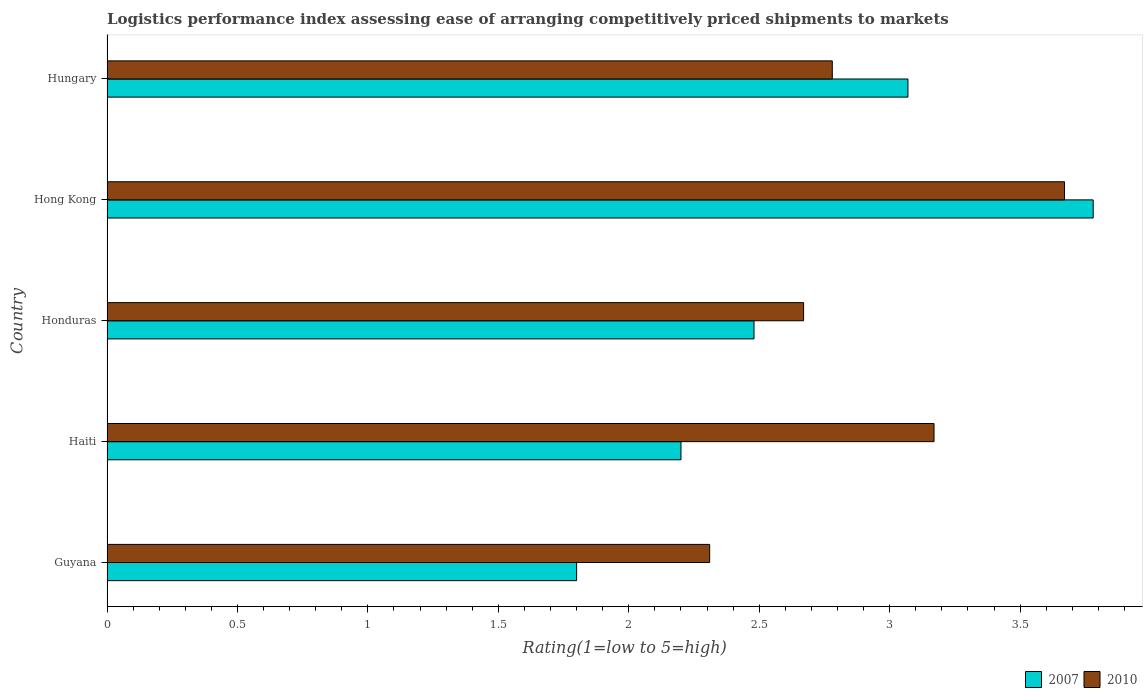Are the number of bars on each tick of the Y-axis equal?
Make the answer very short. Yes. How many bars are there on the 1st tick from the top?
Provide a succinct answer. 2. How many bars are there on the 1st tick from the bottom?
Your answer should be compact. 2. What is the label of the 1st group of bars from the top?
Your response must be concise. Hungary. What is the Logistic performance index in 2010 in Hong Kong?
Provide a short and direct response. 3.67. Across all countries, what is the maximum Logistic performance index in 2007?
Provide a succinct answer. 3.78. Across all countries, what is the minimum Logistic performance index in 2007?
Make the answer very short. 1.8. In which country was the Logistic performance index in 2010 maximum?
Provide a short and direct response. Hong Kong. In which country was the Logistic performance index in 2010 minimum?
Provide a succinct answer. Guyana. What is the total Logistic performance index in 2010 in the graph?
Provide a short and direct response. 14.6. What is the difference between the Logistic performance index in 2010 in Hong Kong and that in Hungary?
Offer a very short reply. 0.89. What is the difference between the Logistic performance index in 2007 in Hong Kong and the Logistic performance index in 2010 in Haiti?
Offer a very short reply. 0.61. What is the average Logistic performance index in 2010 per country?
Provide a short and direct response. 2.92. What is the difference between the Logistic performance index in 2007 and Logistic performance index in 2010 in Haiti?
Offer a very short reply. -0.97. What is the ratio of the Logistic performance index in 2007 in Haiti to that in Honduras?
Provide a succinct answer. 0.89. Is the Logistic performance index in 2007 in Honduras less than that in Hong Kong?
Give a very brief answer. Yes. Is the difference between the Logistic performance index in 2007 in Guyana and Honduras greater than the difference between the Logistic performance index in 2010 in Guyana and Honduras?
Your answer should be very brief. No. What is the difference between the highest and the lowest Logistic performance index in 2010?
Give a very brief answer. 1.36. In how many countries, is the Logistic performance index in 2007 greater than the average Logistic performance index in 2007 taken over all countries?
Your answer should be compact. 2. What does the 1st bar from the top in Hungary represents?
Offer a terse response. 2010. What does the 2nd bar from the bottom in Honduras represents?
Keep it short and to the point. 2010. Are all the bars in the graph horizontal?
Your response must be concise. Yes. What is the difference between two consecutive major ticks on the X-axis?
Make the answer very short. 0.5. Are the values on the major ticks of X-axis written in scientific E-notation?
Offer a terse response. No. Does the graph contain any zero values?
Provide a short and direct response. No. Where does the legend appear in the graph?
Your answer should be compact. Bottom right. How are the legend labels stacked?
Offer a terse response. Horizontal. What is the title of the graph?
Give a very brief answer. Logistics performance index assessing ease of arranging competitively priced shipments to markets. Does "1998" appear as one of the legend labels in the graph?
Your answer should be compact. No. What is the label or title of the X-axis?
Your response must be concise. Rating(1=low to 5=high). What is the label or title of the Y-axis?
Offer a terse response. Country. What is the Rating(1=low to 5=high) in 2007 in Guyana?
Your response must be concise. 1.8. What is the Rating(1=low to 5=high) in 2010 in Guyana?
Provide a succinct answer. 2.31. What is the Rating(1=low to 5=high) in 2007 in Haiti?
Your answer should be very brief. 2.2. What is the Rating(1=low to 5=high) in 2010 in Haiti?
Keep it short and to the point. 3.17. What is the Rating(1=low to 5=high) of 2007 in Honduras?
Give a very brief answer. 2.48. What is the Rating(1=low to 5=high) in 2010 in Honduras?
Keep it short and to the point. 2.67. What is the Rating(1=low to 5=high) of 2007 in Hong Kong?
Ensure brevity in your answer.  3.78. What is the Rating(1=low to 5=high) in 2010 in Hong Kong?
Keep it short and to the point. 3.67. What is the Rating(1=low to 5=high) in 2007 in Hungary?
Your answer should be very brief. 3.07. What is the Rating(1=low to 5=high) of 2010 in Hungary?
Your response must be concise. 2.78. Across all countries, what is the maximum Rating(1=low to 5=high) of 2007?
Your response must be concise. 3.78. Across all countries, what is the maximum Rating(1=low to 5=high) of 2010?
Your answer should be compact. 3.67. Across all countries, what is the minimum Rating(1=low to 5=high) in 2007?
Provide a succinct answer. 1.8. Across all countries, what is the minimum Rating(1=low to 5=high) in 2010?
Keep it short and to the point. 2.31. What is the total Rating(1=low to 5=high) of 2007 in the graph?
Your answer should be very brief. 13.33. What is the difference between the Rating(1=low to 5=high) in 2007 in Guyana and that in Haiti?
Keep it short and to the point. -0.4. What is the difference between the Rating(1=low to 5=high) of 2010 in Guyana and that in Haiti?
Keep it short and to the point. -0.86. What is the difference between the Rating(1=low to 5=high) in 2007 in Guyana and that in Honduras?
Offer a terse response. -0.68. What is the difference between the Rating(1=low to 5=high) in 2010 in Guyana and that in Honduras?
Provide a succinct answer. -0.36. What is the difference between the Rating(1=low to 5=high) in 2007 in Guyana and that in Hong Kong?
Your answer should be very brief. -1.98. What is the difference between the Rating(1=low to 5=high) of 2010 in Guyana and that in Hong Kong?
Make the answer very short. -1.36. What is the difference between the Rating(1=low to 5=high) in 2007 in Guyana and that in Hungary?
Your response must be concise. -1.27. What is the difference between the Rating(1=low to 5=high) in 2010 in Guyana and that in Hungary?
Provide a succinct answer. -0.47. What is the difference between the Rating(1=low to 5=high) of 2007 in Haiti and that in Honduras?
Ensure brevity in your answer.  -0.28. What is the difference between the Rating(1=low to 5=high) of 2010 in Haiti and that in Honduras?
Provide a succinct answer. 0.5. What is the difference between the Rating(1=low to 5=high) in 2007 in Haiti and that in Hong Kong?
Make the answer very short. -1.58. What is the difference between the Rating(1=low to 5=high) in 2007 in Haiti and that in Hungary?
Give a very brief answer. -0.87. What is the difference between the Rating(1=low to 5=high) of 2010 in Haiti and that in Hungary?
Give a very brief answer. 0.39. What is the difference between the Rating(1=low to 5=high) in 2010 in Honduras and that in Hong Kong?
Make the answer very short. -1. What is the difference between the Rating(1=low to 5=high) in 2007 in Honduras and that in Hungary?
Your response must be concise. -0.59. What is the difference between the Rating(1=low to 5=high) of 2010 in Honduras and that in Hungary?
Your answer should be very brief. -0.11. What is the difference between the Rating(1=low to 5=high) of 2007 in Hong Kong and that in Hungary?
Your response must be concise. 0.71. What is the difference between the Rating(1=low to 5=high) in 2010 in Hong Kong and that in Hungary?
Make the answer very short. 0.89. What is the difference between the Rating(1=low to 5=high) in 2007 in Guyana and the Rating(1=low to 5=high) in 2010 in Haiti?
Your response must be concise. -1.37. What is the difference between the Rating(1=low to 5=high) in 2007 in Guyana and the Rating(1=low to 5=high) in 2010 in Honduras?
Ensure brevity in your answer.  -0.87. What is the difference between the Rating(1=low to 5=high) of 2007 in Guyana and the Rating(1=low to 5=high) of 2010 in Hong Kong?
Give a very brief answer. -1.87. What is the difference between the Rating(1=low to 5=high) of 2007 in Guyana and the Rating(1=low to 5=high) of 2010 in Hungary?
Ensure brevity in your answer.  -0.98. What is the difference between the Rating(1=low to 5=high) in 2007 in Haiti and the Rating(1=low to 5=high) in 2010 in Honduras?
Ensure brevity in your answer.  -0.47. What is the difference between the Rating(1=low to 5=high) in 2007 in Haiti and the Rating(1=low to 5=high) in 2010 in Hong Kong?
Your answer should be very brief. -1.47. What is the difference between the Rating(1=low to 5=high) of 2007 in Haiti and the Rating(1=low to 5=high) of 2010 in Hungary?
Make the answer very short. -0.58. What is the difference between the Rating(1=low to 5=high) in 2007 in Honduras and the Rating(1=low to 5=high) in 2010 in Hong Kong?
Ensure brevity in your answer.  -1.19. What is the average Rating(1=low to 5=high) in 2007 per country?
Keep it short and to the point. 2.67. What is the average Rating(1=low to 5=high) in 2010 per country?
Give a very brief answer. 2.92. What is the difference between the Rating(1=low to 5=high) of 2007 and Rating(1=low to 5=high) of 2010 in Guyana?
Your answer should be very brief. -0.51. What is the difference between the Rating(1=low to 5=high) of 2007 and Rating(1=low to 5=high) of 2010 in Haiti?
Your answer should be compact. -0.97. What is the difference between the Rating(1=low to 5=high) in 2007 and Rating(1=low to 5=high) in 2010 in Honduras?
Offer a very short reply. -0.19. What is the difference between the Rating(1=low to 5=high) of 2007 and Rating(1=low to 5=high) of 2010 in Hong Kong?
Make the answer very short. 0.11. What is the difference between the Rating(1=low to 5=high) of 2007 and Rating(1=low to 5=high) of 2010 in Hungary?
Provide a succinct answer. 0.29. What is the ratio of the Rating(1=low to 5=high) of 2007 in Guyana to that in Haiti?
Ensure brevity in your answer.  0.82. What is the ratio of the Rating(1=low to 5=high) in 2010 in Guyana to that in Haiti?
Provide a short and direct response. 0.73. What is the ratio of the Rating(1=low to 5=high) of 2007 in Guyana to that in Honduras?
Your answer should be very brief. 0.73. What is the ratio of the Rating(1=low to 5=high) in 2010 in Guyana to that in Honduras?
Provide a succinct answer. 0.87. What is the ratio of the Rating(1=low to 5=high) of 2007 in Guyana to that in Hong Kong?
Provide a short and direct response. 0.48. What is the ratio of the Rating(1=low to 5=high) in 2010 in Guyana to that in Hong Kong?
Give a very brief answer. 0.63. What is the ratio of the Rating(1=low to 5=high) in 2007 in Guyana to that in Hungary?
Provide a short and direct response. 0.59. What is the ratio of the Rating(1=low to 5=high) in 2010 in Guyana to that in Hungary?
Your answer should be very brief. 0.83. What is the ratio of the Rating(1=low to 5=high) of 2007 in Haiti to that in Honduras?
Provide a succinct answer. 0.89. What is the ratio of the Rating(1=low to 5=high) of 2010 in Haiti to that in Honduras?
Provide a short and direct response. 1.19. What is the ratio of the Rating(1=low to 5=high) in 2007 in Haiti to that in Hong Kong?
Keep it short and to the point. 0.58. What is the ratio of the Rating(1=low to 5=high) of 2010 in Haiti to that in Hong Kong?
Ensure brevity in your answer.  0.86. What is the ratio of the Rating(1=low to 5=high) in 2007 in Haiti to that in Hungary?
Give a very brief answer. 0.72. What is the ratio of the Rating(1=low to 5=high) in 2010 in Haiti to that in Hungary?
Provide a short and direct response. 1.14. What is the ratio of the Rating(1=low to 5=high) in 2007 in Honduras to that in Hong Kong?
Give a very brief answer. 0.66. What is the ratio of the Rating(1=low to 5=high) of 2010 in Honduras to that in Hong Kong?
Your answer should be compact. 0.73. What is the ratio of the Rating(1=low to 5=high) of 2007 in Honduras to that in Hungary?
Provide a succinct answer. 0.81. What is the ratio of the Rating(1=low to 5=high) of 2010 in Honduras to that in Hungary?
Offer a very short reply. 0.96. What is the ratio of the Rating(1=low to 5=high) in 2007 in Hong Kong to that in Hungary?
Make the answer very short. 1.23. What is the ratio of the Rating(1=low to 5=high) of 2010 in Hong Kong to that in Hungary?
Provide a succinct answer. 1.32. What is the difference between the highest and the second highest Rating(1=low to 5=high) in 2007?
Your answer should be compact. 0.71. What is the difference between the highest and the lowest Rating(1=low to 5=high) of 2007?
Provide a short and direct response. 1.98. What is the difference between the highest and the lowest Rating(1=low to 5=high) in 2010?
Offer a very short reply. 1.36. 